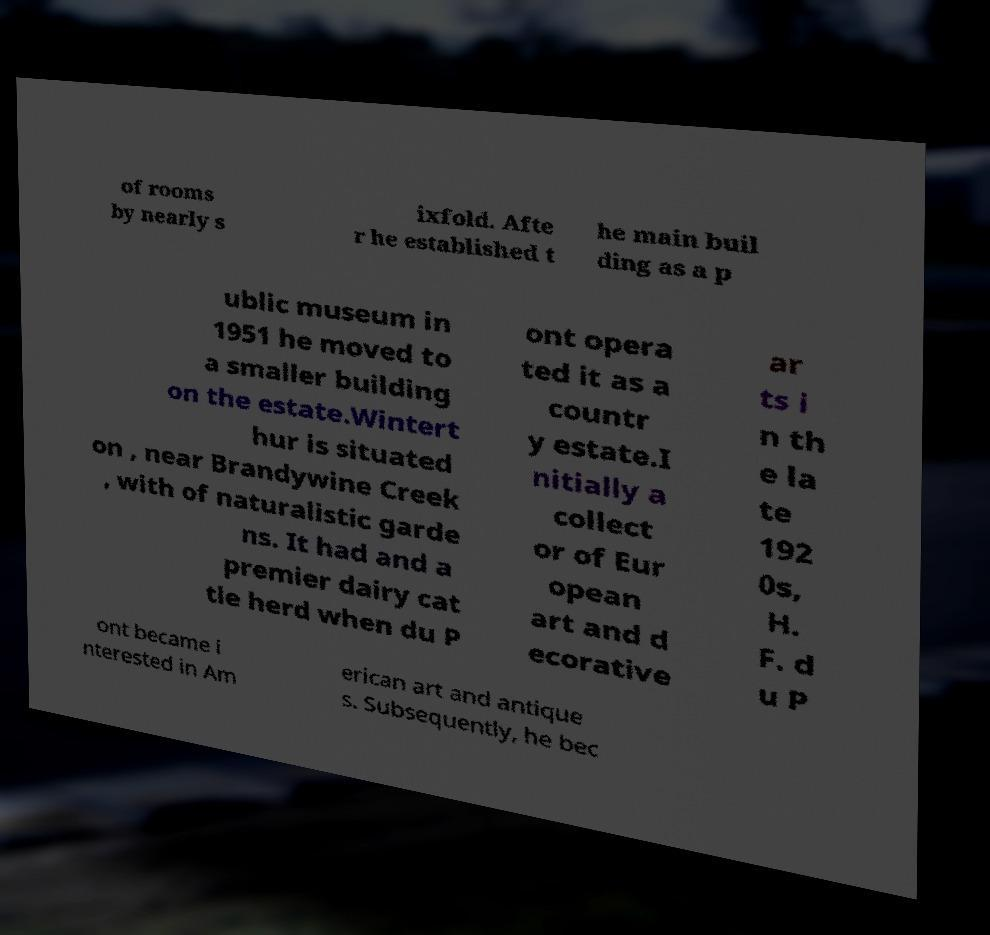Can you accurately transcribe the text from the provided image for me? of rooms by nearly s ixfold. Afte r he established t he main buil ding as a p ublic museum in 1951 he moved to a smaller building on the estate.Wintert hur is situated on , near Brandywine Creek , with of naturalistic garde ns. It had and a premier dairy cat tle herd when du P ont opera ted it as a countr y estate.I nitially a collect or of Eur opean art and d ecorative ar ts i n th e la te 192 0s, H. F. d u P ont became i nterested in Am erican art and antique s. Subsequently, he bec 